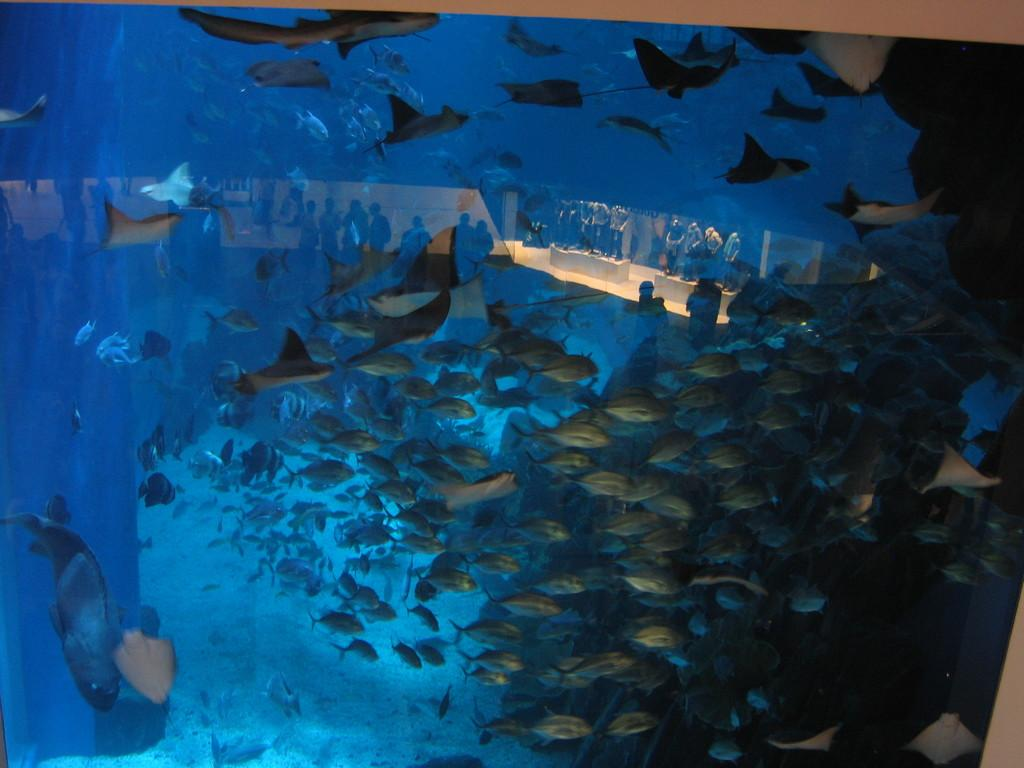What type of animals can be seen in the image? There are many fishes in the water in the image. Can you describe the environment in which the fishes are located? The fishes are in the water in the image. How many fishes can be seen in the image? The image shows many fishes. What type of spot can be seen on the railway in the image? There is no railway or spot present in the image; it features many fishes in the water. How many family members are visible in the image? There are no family members present in the image; it features many fishes in the water. 